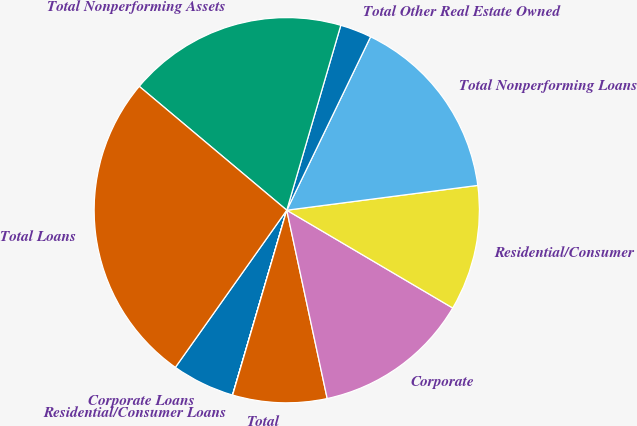<chart> <loc_0><loc_0><loc_500><loc_500><pie_chart><fcel>Corporate Loans<fcel>Residential/Consumer Loans<fcel>Total<fcel>Corporate<fcel>Residential/Consumer<fcel>Total Nonperforming Loans<fcel>Total Other Real Estate Owned<fcel>Total Nonperforming Assets<fcel>Total Loans<nl><fcel>5.27%<fcel>0.01%<fcel>7.9%<fcel>13.16%<fcel>10.53%<fcel>15.78%<fcel>2.64%<fcel>18.41%<fcel>26.3%<nl></chart> 